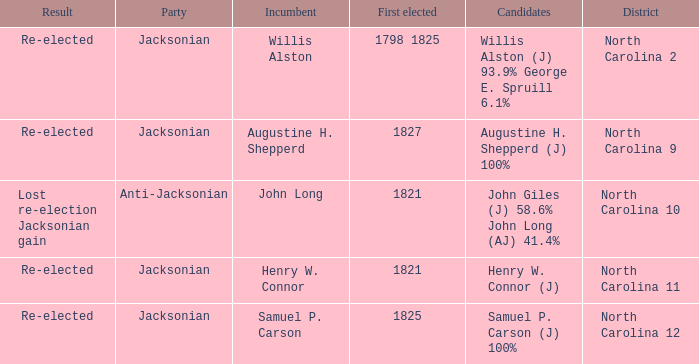Name the result for first elected being 1798 1825 Re-elected. 